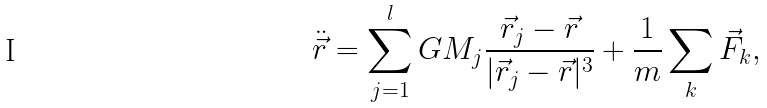<formula> <loc_0><loc_0><loc_500><loc_500>\ddot { \vec { r } } = \sum _ { j = 1 } ^ { l } G M _ { j } \frac { \vec { r } _ { j } - \vec { r } } { | \vec { r } _ { j } - \vec { r } | ^ { 3 } } + \frac { 1 } { m } \sum _ { k } \vec { F } _ { k } ,</formula> 